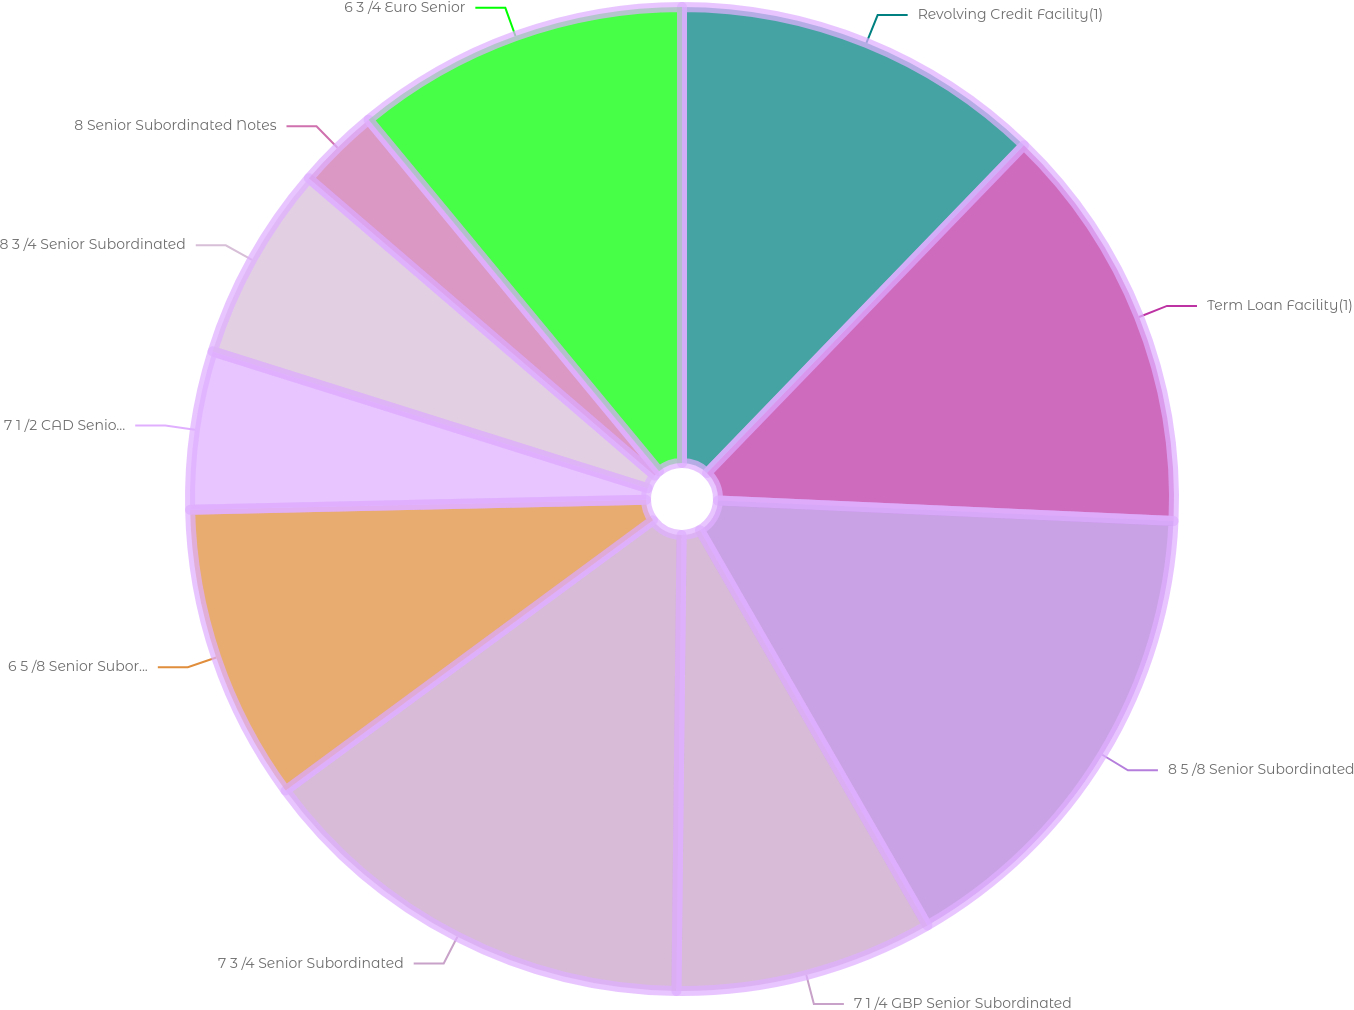<chart> <loc_0><loc_0><loc_500><loc_500><pie_chart><fcel>Revolving Credit Facility(1)<fcel>Term Loan Facility(1)<fcel>8 5 /8 Senior Subordinated<fcel>7 1 /4 GBP Senior Subordinated<fcel>7 3 /4 Senior Subordinated<fcel>6 5 /8 Senior Subordinated<fcel>7 1 /2 CAD Senior Subordinated<fcel>8 3 /4 Senior Subordinated<fcel>8 Senior Subordinated Notes<fcel>6 3 /4 Euro Senior<nl><fcel>12.23%<fcel>13.48%<fcel>15.98%<fcel>8.49%<fcel>14.73%<fcel>9.74%<fcel>5.2%<fcel>6.45%<fcel>2.71%<fcel>10.99%<nl></chart> 